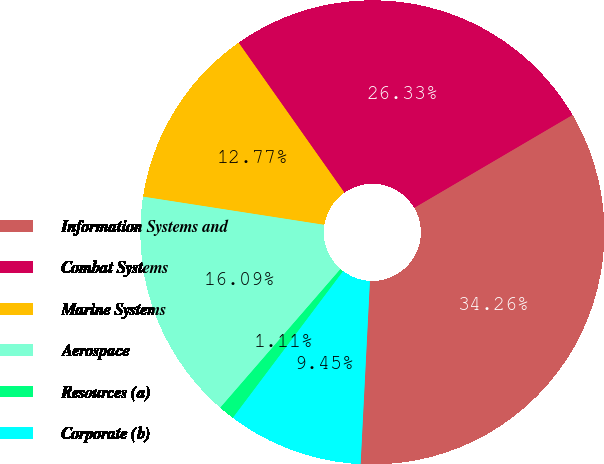Convert chart. <chart><loc_0><loc_0><loc_500><loc_500><pie_chart><fcel>Information Systems and<fcel>Combat Systems<fcel>Marine Systems<fcel>Aerospace<fcel>Resources (a)<fcel>Corporate (b)<nl><fcel>34.26%<fcel>26.33%<fcel>12.77%<fcel>16.09%<fcel>1.11%<fcel>9.45%<nl></chart> 